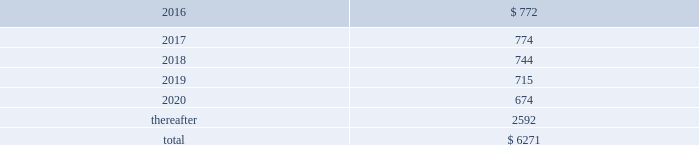Table of contents the company uses some custom components that are not commonly used by its competitors , and new products introduced by the company often utilize custom components available from only one source .
When a component or product uses new technologies , initial capacity constraints may exist until the suppliers 2019 yields have matured or manufacturing capacity has increased .
If the company 2019s supply of components for a new or existing product were delayed or constrained , or if an outsourcing partner delayed shipments of completed products to the company , the company 2019s financial condition and operating results could be materially adversely affected .
The company 2019s business and financial performance could also be materially adversely affected depending on the time required to obtain sufficient quantities from the original source , or to identify and obtain sufficient quantities from an alternative source .
Continued availability of these components at acceptable prices , or at all , may be affected if those suppliers concentrated on the production of common components instead of components customized to meet the company 2019s requirements .
The company has entered into agreements for the supply of many components ; however , there can be no guarantee that the company will be able to extend or renew these agreements on similar terms , or at all .
Therefore , the company remains subject to significant risks of supply shortages and price increases that could materially adversely affect its financial condition and operating results .
Substantially all of the company 2019s hardware products are manufactured by outsourcing partners that are located primarily in asia .
A significant concentration of this manufacturing is currently performed by a small number of outsourcing partners , often in single locations .
Certain of these outsourcing partners are the sole- sourced suppliers of components and manufacturers for many of the company 2019s products .
Although the company works closely with its outsourcing partners on manufacturing schedules , the company 2019s operating results could be adversely affected if its outsourcing partners were unable to meet their production commitments .
The company 2019s purchase commitments typically cover its requirements for periods up to 150 days .
Other off-balance sheet commitments operating leases the company leases various equipment and facilities , including retail space , under noncancelable operating lease arrangements .
The company does not currently utilize any other off-balance sheet financing arrangements .
The major facility leases are typically for terms not exceeding 10 years and generally contain multi-year renewal options .
As of september 26 , 2015 , the company had a total of 463 retail stores .
Leases for retail space are for terms ranging from five to 20 years , the majority of which are for 10 years , and often contain multi-year renewal options .
As of september 26 , 2015 , the company 2019s total future minimum lease payments under noncancelable operating leases were $ 6.3 billion , of which $ 3.6 billion related to leases for retail space .
Rent expense under all operating leases , including both cancelable and noncancelable leases , was $ 794 million , $ 717 million and $ 645 million in 2015 , 2014 and 2013 , respectively .
Future minimum lease payments under noncancelable operating leases having remaining terms in excess of one year as of september 26 , 2015 , are as follows ( in millions ) : .
Other commitments the company utilizes several outsourcing partners to manufacture sub-assemblies for the company 2019s products and to perform final assembly and testing of finished products .
These outsourcing partners acquire components and build product based on demand information supplied by the company , which typically covers periods up to 150 days .
The company also obtains individual components for its products from a wide variety of individual suppliers .
Consistent with industry practice , the company acquires components through a combination of purchase orders , supplier contracts and open orders based on projected demand information .
Where appropriate , the purchases are applied to inventory component prepayments that are outstanding with the respective supplier .
As of september 26 , 2015 , the company had outstanding off-balance sheet third-party manufacturing commitments and component purchase commitments of $ 29.5 billion .
Apple inc .
| 2015 form 10-k | 65 .
What percentage of future minimum lease payments under noncancelable operating leases are due in 2018? 
Computations: (744 / 6271)
Answer: 0.11864. 